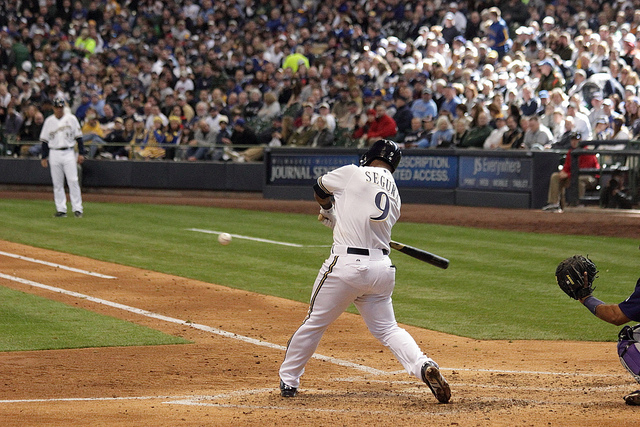Please transcribe the text information in this image. 9 